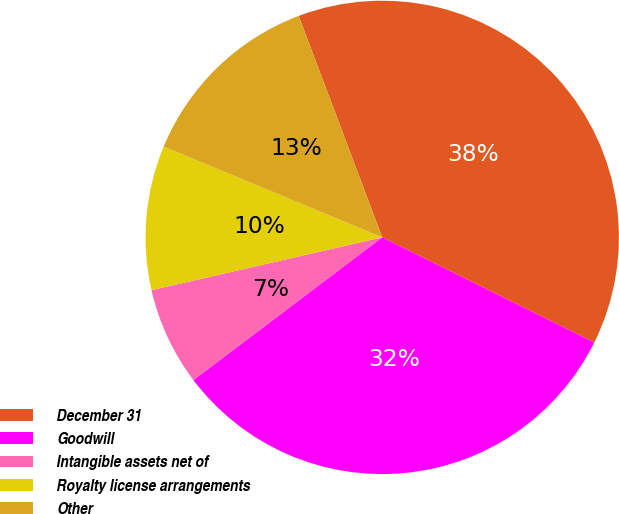Convert chart to OTSL. <chart><loc_0><loc_0><loc_500><loc_500><pie_chart><fcel>December 31<fcel>Goodwill<fcel>Intangible assets net of<fcel>Royalty license arrangements<fcel>Other<nl><fcel>38.07%<fcel>32.37%<fcel>6.72%<fcel>9.85%<fcel>12.99%<nl></chart> 